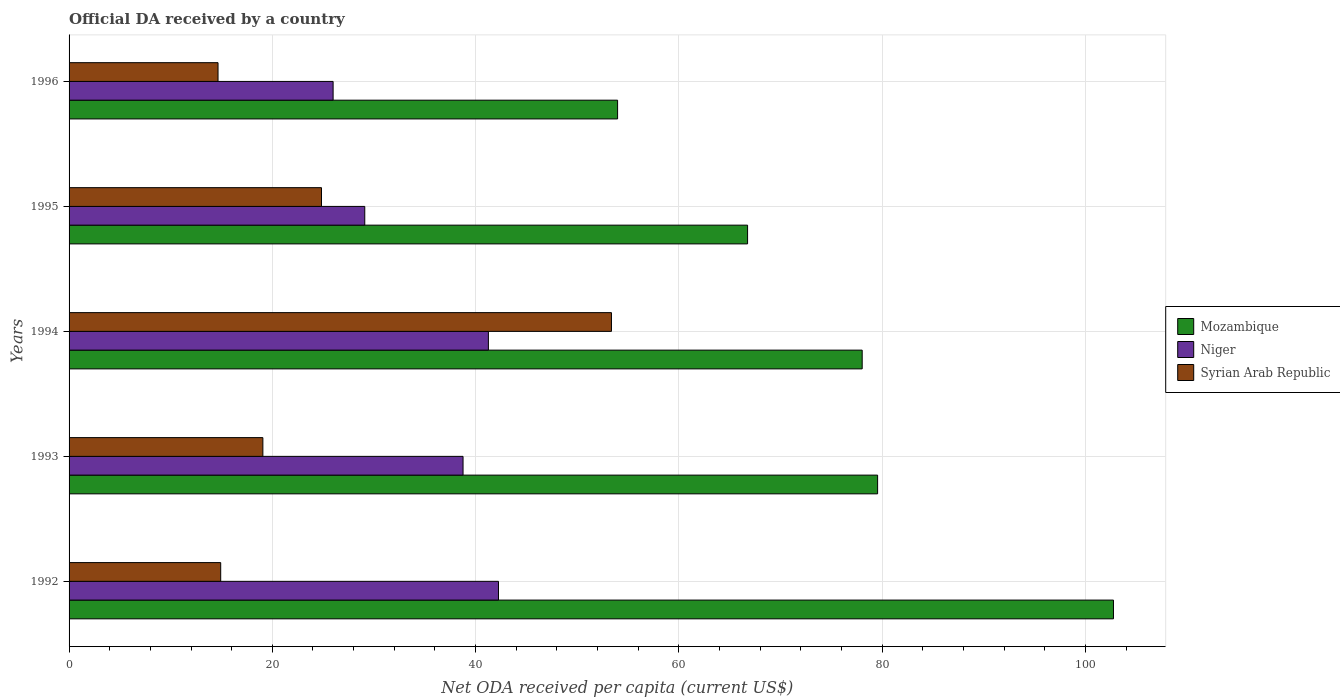How many different coloured bars are there?
Provide a short and direct response. 3. How many groups of bars are there?
Your answer should be compact. 5. Are the number of bars per tick equal to the number of legend labels?
Offer a very short reply. Yes. Are the number of bars on each tick of the Y-axis equal?
Your answer should be compact. Yes. How many bars are there on the 5th tick from the top?
Keep it short and to the point. 3. In how many cases, is the number of bars for a given year not equal to the number of legend labels?
Ensure brevity in your answer.  0. What is the ODA received in in Mozambique in 1996?
Your answer should be compact. 53.97. Across all years, what is the maximum ODA received in in Mozambique?
Offer a very short reply. 102.77. Across all years, what is the minimum ODA received in in Niger?
Ensure brevity in your answer.  25.98. In which year was the ODA received in in Niger minimum?
Keep it short and to the point. 1996. What is the total ODA received in in Mozambique in the graph?
Your response must be concise. 381.1. What is the difference between the ODA received in in Syrian Arab Republic in 1992 and that in 1996?
Give a very brief answer. 0.26. What is the difference between the ODA received in in Syrian Arab Republic in 1994 and the ODA received in in Niger in 1995?
Your answer should be compact. 24.27. What is the average ODA received in in Niger per year?
Make the answer very short. 35.47. In the year 1994, what is the difference between the ODA received in in Niger and ODA received in in Mozambique?
Keep it short and to the point. -36.78. In how many years, is the ODA received in in Mozambique greater than 28 US$?
Ensure brevity in your answer.  5. What is the ratio of the ODA received in in Niger in 1993 to that in 1995?
Offer a terse response. 1.33. Is the difference between the ODA received in in Niger in 1993 and 1995 greater than the difference between the ODA received in in Mozambique in 1993 and 1995?
Your answer should be very brief. No. What is the difference between the highest and the second highest ODA received in in Niger?
Your response must be concise. 0.99. What is the difference between the highest and the lowest ODA received in in Mozambique?
Provide a succinct answer. 48.79. In how many years, is the ODA received in in Syrian Arab Republic greater than the average ODA received in in Syrian Arab Republic taken over all years?
Make the answer very short. 1. What does the 2nd bar from the top in 1994 represents?
Offer a terse response. Niger. What does the 2nd bar from the bottom in 1992 represents?
Offer a terse response. Niger. Is it the case that in every year, the sum of the ODA received in in Niger and ODA received in in Mozambique is greater than the ODA received in in Syrian Arab Republic?
Offer a very short reply. Yes. Are all the bars in the graph horizontal?
Offer a very short reply. Yes. How many years are there in the graph?
Offer a very short reply. 5. What is the difference between two consecutive major ticks on the X-axis?
Provide a short and direct response. 20. Are the values on the major ticks of X-axis written in scientific E-notation?
Give a very brief answer. No. How many legend labels are there?
Keep it short and to the point. 3. How are the legend labels stacked?
Make the answer very short. Vertical. What is the title of the graph?
Provide a succinct answer. Official DA received by a country. Does "Sao Tome and Principe" appear as one of the legend labels in the graph?
Make the answer very short. No. What is the label or title of the X-axis?
Your answer should be compact. Net ODA received per capita (current US$). What is the Net ODA received per capita (current US$) in Mozambique in 1992?
Provide a short and direct response. 102.77. What is the Net ODA received per capita (current US$) of Niger in 1992?
Offer a terse response. 42.25. What is the Net ODA received per capita (current US$) of Syrian Arab Republic in 1992?
Ensure brevity in your answer.  14.92. What is the Net ODA received per capita (current US$) of Mozambique in 1993?
Keep it short and to the point. 79.56. What is the Net ODA received per capita (current US$) of Niger in 1993?
Offer a very short reply. 38.77. What is the Net ODA received per capita (current US$) in Syrian Arab Republic in 1993?
Provide a short and direct response. 19.07. What is the Net ODA received per capita (current US$) in Mozambique in 1994?
Your answer should be very brief. 78.04. What is the Net ODA received per capita (current US$) in Niger in 1994?
Offer a very short reply. 41.26. What is the Net ODA received per capita (current US$) of Syrian Arab Republic in 1994?
Make the answer very short. 53.37. What is the Net ODA received per capita (current US$) of Mozambique in 1995?
Your response must be concise. 66.76. What is the Net ODA received per capita (current US$) of Niger in 1995?
Keep it short and to the point. 29.1. What is the Net ODA received per capita (current US$) of Syrian Arab Republic in 1995?
Provide a succinct answer. 24.84. What is the Net ODA received per capita (current US$) of Mozambique in 1996?
Your answer should be compact. 53.97. What is the Net ODA received per capita (current US$) of Niger in 1996?
Offer a very short reply. 25.98. What is the Net ODA received per capita (current US$) in Syrian Arab Republic in 1996?
Your answer should be very brief. 14.66. Across all years, what is the maximum Net ODA received per capita (current US$) in Mozambique?
Your answer should be compact. 102.77. Across all years, what is the maximum Net ODA received per capita (current US$) in Niger?
Ensure brevity in your answer.  42.25. Across all years, what is the maximum Net ODA received per capita (current US$) of Syrian Arab Republic?
Your answer should be very brief. 53.37. Across all years, what is the minimum Net ODA received per capita (current US$) of Mozambique?
Provide a succinct answer. 53.97. Across all years, what is the minimum Net ODA received per capita (current US$) of Niger?
Offer a terse response. 25.98. Across all years, what is the minimum Net ODA received per capita (current US$) in Syrian Arab Republic?
Provide a short and direct response. 14.66. What is the total Net ODA received per capita (current US$) in Mozambique in the graph?
Offer a very short reply. 381.1. What is the total Net ODA received per capita (current US$) of Niger in the graph?
Give a very brief answer. 177.35. What is the total Net ODA received per capita (current US$) of Syrian Arab Republic in the graph?
Your answer should be compact. 126.85. What is the difference between the Net ODA received per capita (current US$) of Mozambique in 1992 and that in 1993?
Ensure brevity in your answer.  23.21. What is the difference between the Net ODA received per capita (current US$) of Niger in 1992 and that in 1993?
Ensure brevity in your answer.  3.49. What is the difference between the Net ODA received per capita (current US$) in Syrian Arab Republic in 1992 and that in 1993?
Offer a terse response. -4.15. What is the difference between the Net ODA received per capita (current US$) in Mozambique in 1992 and that in 1994?
Give a very brief answer. 24.73. What is the difference between the Net ODA received per capita (current US$) of Syrian Arab Republic in 1992 and that in 1994?
Your answer should be very brief. -38.45. What is the difference between the Net ODA received per capita (current US$) of Mozambique in 1992 and that in 1995?
Ensure brevity in your answer.  36. What is the difference between the Net ODA received per capita (current US$) of Niger in 1992 and that in 1995?
Provide a short and direct response. 13.16. What is the difference between the Net ODA received per capita (current US$) in Syrian Arab Republic in 1992 and that in 1995?
Give a very brief answer. -9.92. What is the difference between the Net ODA received per capita (current US$) of Mozambique in 1992 and that in 1996?
Provide a succinct answer. 48.79. What is the difference between the Net ODA received per capita (current US$) in Niger in 1992 and that in 1996?
Keep it short and to the point. 16.27. What is the difference between the Net ODA received per capita (current US$) of Syrian Arab Republic in 1992 and that in 1996?
Your response must be concise. 0.26. What is the difference between the Net ODA received per capita (current US$) of Mozambique in 1993 and that in 1994?
Your answer should be very brief. 1.52. What is the difference between the Net ODA received per capita (current US$) in Niger in 1993 and that in 1994?
Provide a succinct answer. -2.49. What is the difference between the Net ODA received per capita (current US$) of Syrian Arab Republic in 1993 and that in 1994?
Your answer should be compact. -34.3. What is the difference between the Net ODA received per capita (current US$) of Mozambique in 1993 and that in 1995?
Offer a terse response. 12.8. What is the difference between the Net ODA received per capita (current US$) in Niger in 1993 and that in 1995?
Ensure brevity in your answer.  9.67. What is the difference between the Net ODA received per capita (current US$) in Syrian Arab Republic in 1993 and that in 1995?
Give a very brief answer. -5.77. What is the difference between the Net ODA received per capita (current US$) in Mozambique in 1993 and that in 1996?
Your answer should be very brief. 25.58. What is the difference between the Net ODA received per capita (current US$) of Niger in 1993 and that in 1996?
Ensure brevity in your answer.  12.78. What is the difference between the Net ODA received per capita (current US$) of Syrian Arab Republic in 1993 and that in 1996?
Ensure brevity in your answer.  4.41. What is the difference between the Net ODA received per capita (current US$) in Mozambique in 1994 and that in 1995?
Offer a very short reply. 11.28. What is the difference between the Net ODA received per capita (current US$) in Niger in 1994 and that in 1995?
Provide a short and direct response. 12.16. What is the difference between the Net ODA received per capita (current US$) of Syrian Arab Republic in 1994 and that in 1995?
Your response must be concise. 28.53. What is the difference between the Net ODA received per capita (current US$) in Mozambique in 1994 and that in 1996?
Your response must be concise. 24.07. What is the difference between the Net ODA received per capita (current US$) of Niger in 1994 and that in 1996?
Provide a short and direct response. 15.28. What is the difference between the Net ODA received per capita (current US$) in Syrian Arab Republic in 1994 and that in 1996?
Offer a terse response. 38.71. What is the difference between the Net ODA received per capita (current US$) of Mozambique in 1995 and that in 1996?
Make the answer very short. 12.79. What is the difference between the Net ODA received per capita (current US$) of Niger in 1995 and that in 1996?
Your answer should be compact. 3.11. What is the difference between the Net ODA received per capita (current US$) of Syrian Arab Republic in 1995 and that in 1996?
Keep it short and to the point. 10.18. What is the difference between the Net ODA received per capita (current US$) in Mozambique in 1992 and the Net ODA received per capita (current US$) in Niger in 1993?
Your answer should be very brief. 64. What is the difference between the Net ODA received per capita (current US$) of Mozambique in 1992 and the Net ODA received per capita (current US$) of Syrian Arab Republic in 1993?
Ensure brevity in your answer.  83.7. What is the difference between the Net ODA received per capita (current US$) of Niger in 1992 and the Net ODA received per capita (current US$) of Syrian Arab Republic in 1993?
Make the answer very short. 23.18. What is the difference between the Net ODA received per capita (current US$) in Mozambique in 1992 and the Net ODA received per capita (current US$) in Niger in 1994?
Provide a short and direct response. 61.51. What is the difference between the Net ODA received per capita (current US$) of Mozambique in 1992 and the Net ODA received per capita (current US$) of Syrian Arab Republic in 1994?
Provide a short and direct response. 49.4. What is the difference between the Net ODA received per capita (current US$) of Niger in 1992 and the Net ODA received per capita (current US$) of Syrian Arab Republic in 1994?
Provide a succinct answer. -11.12. What is the difference between the Net ODA received per capita (current US$) of Mozambique in 1992 and the Net ODA received per capita (current US$) of Niger in 1995?
Your response must be concise. 73.67. What is the difference between the Net ODA received per capita (current US$) of Mozambique in 1992 and the Net ODA received per capita (current US$) of Syrian Arab Republic in 1995?
Your response must be concise. 77.93. What is the difference between the Net ODA received per capita (current US$) in Niger in 1992 and the Net ODA received per capita (current US$) in Syrian Arab Republic in 1995?
Keep it short and to the point. 17.42. What is the difference between the Net ODA received per capita (current US$) in Mozambique in 1992 and the Net ODA received per capita (current US$) in Niger in 1996?
Keep it short and to the point. 76.78. What is the difference between the Net ODA received per capita (current US$) in Mozambique in 1992 and the Net ODA received per capita (current US$) in Syrian Arab Republic in 1996?
Your answer should be compact. 88.11. What is the difference between the Net ODA received per capita (current US$) in Niger in 1992 and the Net ODA received per capita (current US$) in Syrian Arab Republic in 1996?
Your answer should be compact. 27.6. What is the difference between the Net ODA received per capita (current US$) of Mozambique in 1993 and the Net ODA received per capita (current US$) of Niger in 1994?
Make the answer very short. 38.3. What is the difference between the Net ODA received per capita (current US$) of Mozambique in 1993 and the Net ODA received per capita (current US$) of Syrian Arab Republic in 1994?
Make the answer very short. 26.19. What is the difference between the Net ODA received per capita (current US$) of Niger in 1993 and the Net ODA received per capita (current US$) of Syrian Arab Republic in 1994?
Offer a very short reply. -14.6. What is the difference between the Net ODA received per capita (current US$) of Mozambique in 1993 and the Net ODA received per capita (current US$) of Niger in 1995?
Offer a terse response. 50.46. What is the difference between the Net ODA received per capita (current US$) of Mozambique in 1993 and the Net ODA received per capita (current US$) of Syrian Arab Republic in 1995?
Offer a very short reply. 54.72. What is the difference between the Net ODA received per capita (current US$) in Niger in 1993 and the Net ODA received per capita (current US$) in Syrian Arab Republic in 1995?
Your response must be concise. 13.93. What is the difference between the Net ODA received per capita (current US$) of Mozambique in 1993 and the Net ODA received per capita (current US$) of Niger in 1996?
Make the answer very short. 53.58. What is the difference between the Net ODA received per capita (current US$) of Mozambique in 1993 and the Net ODA received per capita (current US$) of Syrian Arab Republic in 1996?
Keep it short and to the point. 64.9. What is the difference between the Net ODA received per capita (current US$) of Niger in 1993 and the Net ODA received per capita (current US$) of Syrian Arab Republic in 1996?
Your answer should be compact. 24.11. What is the difference between the Net ODA received per capita (current US$) in Mozambique in 1994 and the Net ODA received per capita (current US$) in Niger in 1995?
Keep it short and to the point. 48.94. What is the difference between the Net ODA received per capita (current US$) in Mozambique in 1994 and the Net ODA received per capita (current US$) in Syrian Arab Republic in 1995?
Give a very brief answer. 53.2. What is the difference between the Net ODA received per capita (current US$) in Niger in 1994 and the Net ODA received per capita (current US$) in Syrian Arab Republic in 1995?
Offer a terse response. 16.42. What is the difference between the Net ODA received per capita (current US$) in Mozambique in 1994 and the Net ODA received per capita (current US$) in Niger in 1996?
Ensure brevity in your answer.  52.06. What is the difference between the Net ODA received per capita (current US$) of Mozambique in 1994 and the Net ODA received per capita (current US$) of Syrian Arab Republic in 1996?
Your answer should be compact. 63.38. What is the difference between the Net ODA received per capita (current US$) in Niger in 1994 and the Net ODA received per capita (current US$) in Syrian Arab Republic in 1996?
Your response must be concise. 26.6. What is the difference between the Net ODA received per capita (current US$) of Mozambique in 1995 and the Net ODA received per capita (current US$) of Niger in 1996?
Provide a short and direct response. 40.78. What is the difference between the Net ODA received per capita (current US$) of Mozambique in 1995 and the Net ODA received per capita (current US$) of Syrian Arab Republic in 1996?
Keep it short and to the point. 52.1. What is the difference between the Net ODA received per capita (current US$) in Niger in 1995 and the Net ODA received per capita (current US$) in Syrian Arab Republic in 1996?
Your response must be concise. 14.44. What is the average Net ODA received per capita (current US$) in Mozambique per year?
Your answer should be compact. 76.22. What is the average Net ODA received per capita (current US$) in Niger per year?
Offer a very short reply. 35.47. What is the average Net ODA received per capita (current US$) in Syrian Arab Republic per year?
Your answer should be compact. 25.37. In the year 1992, what is the difference between the Net ODA received per capita (current US$) of Mozambique and Net ODA received per capita (current US$) of Niger?
Give a very brief answer. 60.51. In the year 1992, what is the difference between the Net ODA received per capita (current US$) of Mozambique and Net ODA received per capita (current US$) of Syrian Arab Republic?
Provide a short and direct response. 87.85. In the year 1992, what is the difference between the Net ODA received per capita (current US$) of Niger and Net ODA received per capita (current US$) of Syrian Arab Republic?
Your response must be concise. 27.33. In the year 1993, what is the difference between the Net ODA received per capita (current US$) in Mozambique and Net ODA received per capita (current US$) in Niger?
Give a very brief answer. 40.79. In the year 1993, what is the difference between the Net ODA received per capita (current US$) of Mozambique and Net ODA received per capita (current US$) of Syrian Arab Republic?
Provide a short and direct response. 60.49. In the year 1993, what is the difference between the Net ODA received per capita (current US$) in Niger and Net ODA received per capita (current US$) in Syrian Arab Republic?
Your response must be concise. 19.7. In the year 1994, what is the difference between the Net ODA received per capita (current US$) of Mozambique and Net ODA received per capita (current US$) of Niger?
Make the answer very short. 36.78. In the year 1994, what is the difference between the Net ODA received per capita (current US$) in Mozambique and Net ODA received per capita (current US$) in Syrian Arab Republic?
Provide a succinct answer. 24.67. In the year 1994, what is the difference between the Net ODA received per capita (current US$) of Niger and Net ODA received per capita (current US$) of Syrian Arab Republic?
Provide a succinct answer. -12.11. In the year 1995, what is the difference between the Net ODA received per capita (current US$) in Mozambique and Net ODA received per capita (current US$) in Niger?
Ensure brevity in your answer.  37.67. In the year 1995, what is the difference between the Net ODA received per capita (current US$) in Mozambique and Net ODA received per capita (current US$) in Syrian Arab Republic?
Make the answer very short. 41.92. In the year 1995, what is the difference between the Net ODA received per capita (current US$) in Niger and Net ODA received per capita (current US$) in Syrian Arab Republic?
Give a very brief answer. 4.26. In the year 1996, what is the difference between the Net ODA received per capita (current US$) in Mozambique and Net ODA received per capita (current US$) in Niger?
Your answer should be very brief. 27.99. In the year 1996, what is the difference between the Net ODA received per capita (current US$) of Mozambique and Net ODA received per capita (current US$) of Syrian Arab Republic?
Offer a terse response. 39.32. In the year 1996, what is the difference between the Net ODA received per capita (current US$) of Niger and Net ODA received per capita (current US$) of Syrian Arab Republic?
Keep it short and to the point. 11.32. What is the ratio of the Net ODA received per capita (current US$) in Mozambique in 1992 to that in 1993?
Provide a succinct answer. 1.29. What is the ratio of the Net ODA received per capita (current US$) of Niger in 1992 to that in 1993?
Your response must be concise. 1.09. What is the ratio of the Net ODA received per capita (current US$) of Syrian Arab Republic in 1992 to that in 1993?
Your answer should be very brief. 0.78. What is the ratio of the Net ODA received per capita (current US$) in Mozambique in 1992 to that in 1994?
Ensure brevity in your answer.  1.32. What is the ratio of the Net ODA received per capita (current US$) in Niger in 1992 to that in 1994?
Provide a succinct answer. 1.02. What is the ratio of the Net ODA received per capita (current US$) in Syrian Arab Republic in 1992 to that in 1994?
Ensure brevity in your answer.  0.28. What is the ratio of the Net ODA received per capita (current US$) of Mozambique in 1992 to that in 1995?
Keep it short and to the point. 1.54. What is the ratio of the Net ODA received per capita (current US$) in Niger in 1992 to that in 1995?
Ensure brevity in your answer.  1.45. What is the ratio of the Net ODA received per capita (current US$) in Syrian Arab Republic in 1992 to that in 1995?
Keep it short and to the point. 0.6. What is the ratio of the Net ODA received per capita (current US$) in Mozambique in 1992 to that in 1996?
Your answer should be very brief. 1.9. What is the ratio of the Net ODA received per capita (current US$) of Niger in 1992 to that in 1996?
Keep it short and to the point. 1.63. What is the ratio of the Net ODA received per capita (current US$) in Syrian Arab Republic in 1992 to that in 1996?
Your answer should be compact. 1.02. What is the ratio of the Net ODA received per capita (current US$) of Mozambique in 1993 to that in 1994?
Your answer should be compact. 1.02. What is the ratio of the Net ODA received per capita (current US$) in Niger in 1993 to that in 1994?
Ensure brevity in your answer.  0.94. What is the ratio of the Net ODA received per capita (current US$) in Syrian Arab Republic in 1993 to that in 1994?
Ensure brevity in your answer.  0.36. What is the ratio of the Net ODA received per capita (current US$) of Mozambique in 1993 to that in 1995?
Offer a very short reply. 1.19. What is the ratio of the Net ODA received per capita (current US$) in Niger in 1993 to that in 1995?
Your answer should be compact. 1.33. What is the ratio of the Net ODA received per capita (current US$) in Syrian Arab Republic in 1993 to that in 1995?
Make the answer very short. 0.77. What is the ratio of the Net ODA received per capita (current US$) in Mozambique in 1993 to that in 1996?
Keep it short and to the point. 1.47. What is the ratio of the Net ODA received per capita (current US$) of Niger in 1993 to that in 1996?
Give a very brief answer. 1.49. What is the ratio of the Net ODA received per capita (current US$) in Syrian Arab Republic in 1993 to that in 1996?
Make the answer very short. 1.3. What is the ratio of the Net ODA received per capita (current US$) in Mozambique in 1994 to that in 1995?
Your response must be concise. 1.17. What is the ratio of the Net ODA received per capita (current US$) of Niger in 1994 to that in 1995?
Your answer should be very brief. 1.42. What is the ratio of the Net ODA received per capita (current US$) of Syrian Arab Republic in 1994 to that in 1995?
Offer a terse response. 2.15. What is the ratio of the Net ODA received per capita (current US$) in Mozambique in 1994 to that in 1996?
Provide a succinct answer. 1.45. What is the ratio of the Net ODA received per capita (current US$) in Niger in 1994 to that in 1996?
Give a very brief answer. 1.59. What is the ratio of the Net ODA received per capita (current US$) of Syrian Arab Republic in 1994 to that in 1996?
Your answer should be very brief. 3.64. What is the ratio of the Net ODA received per capita (current US$) in Mozambique in 1995 to that in 1996?
Make the answer very short. 1.24. What is the ratio of the Net ODA received per capita (current US$) of Niger in 1995 to that in 1996?
Provide a succinct answer. 1.12. What is the ratio of the Net ODA received per capita (current US$) of Syrian Arab Republic in 1995 to that in 1996?
Offer a very short reply. 1.69. What is the difference between the highest and the second highest Net ODA received per capita (current US$) in Mozambique?
Provide a short and direct response. 23.21. What is the difference between the highest and the second highest Net ODA received per capita (current US$) in Niger?
Offer a very short reply. 0.99. What is the difference between the highest and the second highest Net ODA received per capita (current US$) of Syrian Arab Republic?
Your answer should be compact. 28.53. What is the difference between the highest and the lowest Net ODA received per capita (current US$) in Mozambique?
Provide a short and direct response. 48.79. What is the difference between the highest and the lowest Net ODA received per capita (current US$) in Niger?
Your answer should be very brief. 16.27. What is the difference between the highest and the lowest Net ODA received per capita (current US$) in Syrian Arab Republic?
Your answer should be compact. 38.71. 